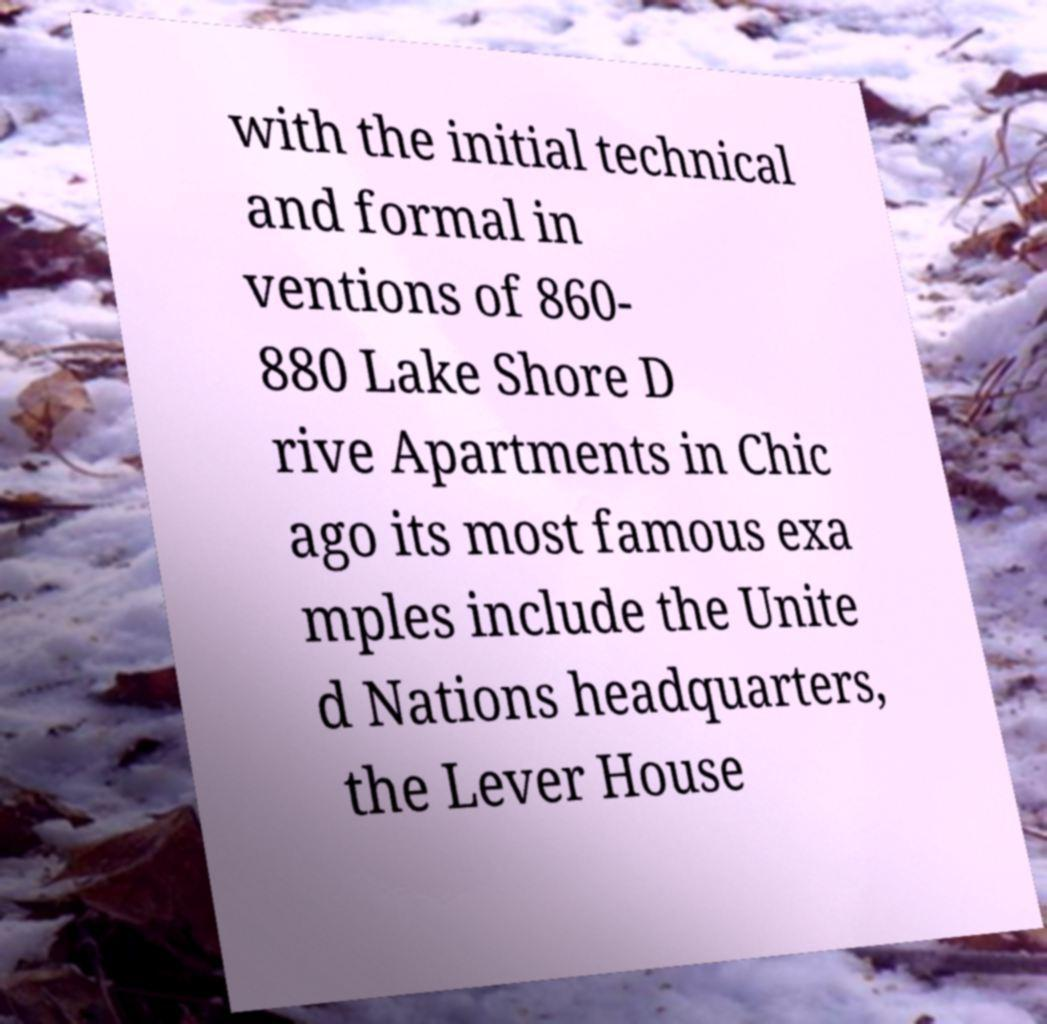Please identify and transcribe the text found in this image. with the initial technical and formal in ventions of 860- 880 Lake Shore D rive Apartments in Chic ago its most famous exa mples include the Unite d Nations headquarters, the Lever House 